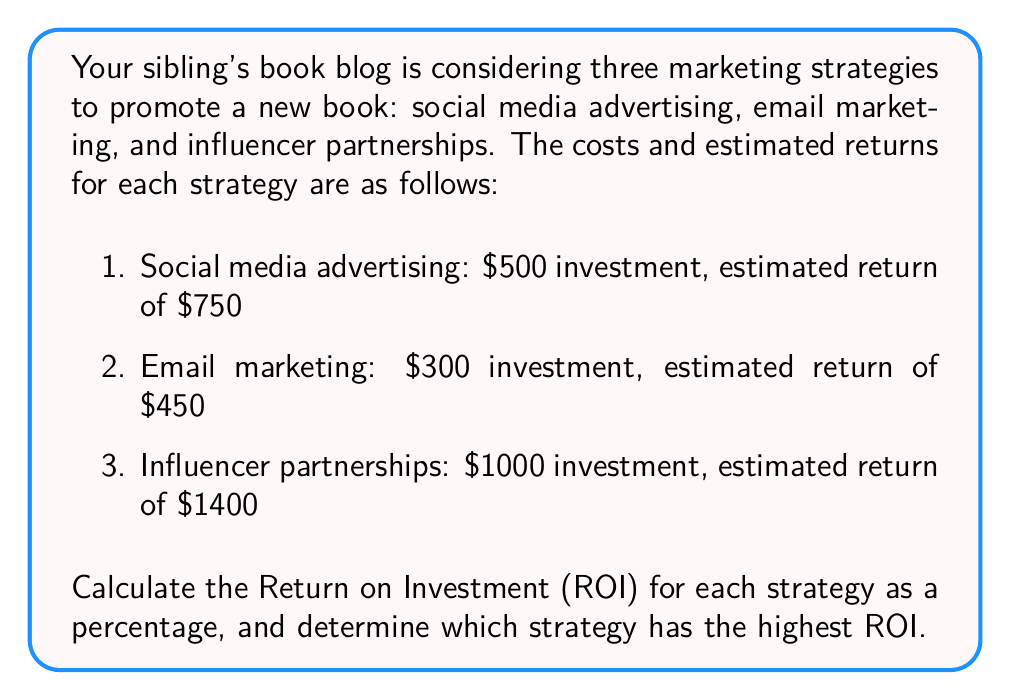Can you solve this math problem? To calculate the Return on Investment (ROI) for each marketing strategy, we'll use the formula:

$$ROI = \frac{\text{Net Profit}}{\text{Investment Cost}} \times 100\%$$

Where Net Profit is the difference between the estimated return and the investment cost.

1. Social media advertising:
   Net Profit = $750 - $500 = $250
   $$ROI_{social} = \frac{250}{500} \times 100\% = 50\%$$

2. Email marketing:
   Net Profit = $450 - $300 = $150
   $$ROI_{email} = \frac{150}{300} \times 100\% = 50\%$$

3. Influencer partnerships:
   Net Profit = $1400 - $1000 = $400
   $$ROI_{influencer} = \frac{400}{1000} \times 100\% = 40\%$$

Comparing the ROI percentages:
Social media advertising: 50%
Email marketing: 50%
Influencer partnerships: 40%

The highest ROI is shared by social media advertising and email marketing at 50%.
Answer: Social media advertising and email marketing have the highest ROI at 50%. 